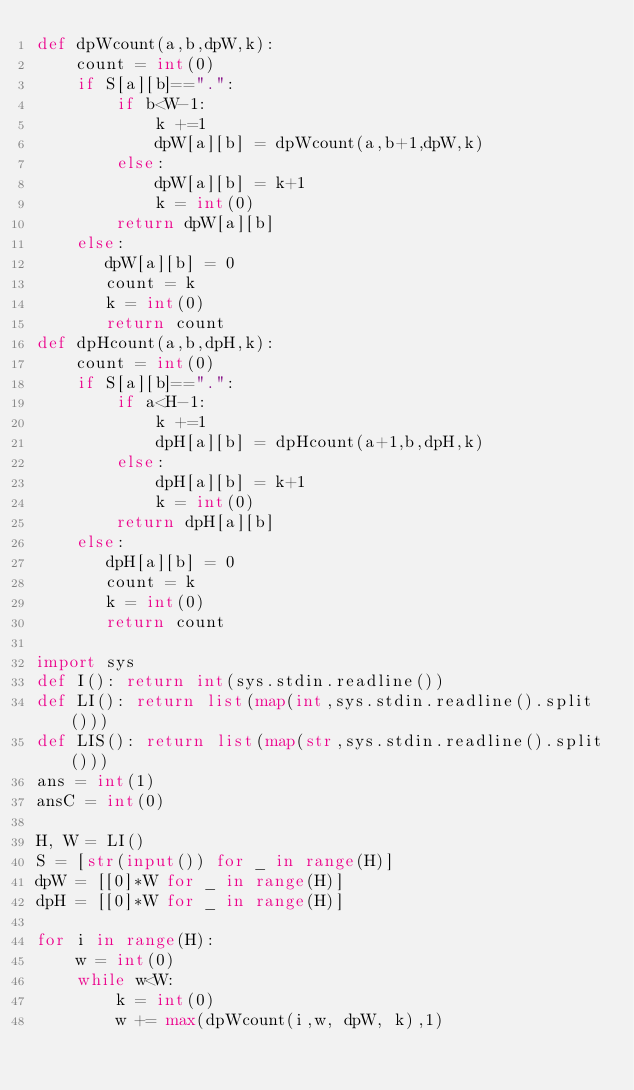<code> <loc_0><loc_0><loc_500><loc_500><_Python_>def dpWcount(a,b,dpW,k):
    count = int(0)
    if S[a][b]==".":
        if b<W-1:
            k +=1
            dpW[a][b] = dpWcount(a,b+1,dpW,k)
        else:
            dpW[a][b] = k+1
            k = int(0)
        return dpW[a][b]
    else:
       dpW[a][b] = 0
       count = k
       k = int(0)
       return count
def dpHcount(a,b,dpH,k):
    count = int(0)
    if S[a][b]==".":
        if a<H-1:
            k +=1
            dpH[a][b] = dpHcount(a+1,b,dpH,k)
        else:
            dpH[a][b] = k+1
            k = int(0)
        return dpH[a][b]
    else:
       dpH[a][b] = 0
       count = k
       k = int(0)
       return count

import sys
def I(): return int(sys.stdin.readline())
def LI(): return list(map(int,sys.stdin.readline().split()))
def LIS(): return list(map(str,sys.stdin.readline().split()))
ans = int(1)
ansC = int(0)

H, W = LI()
S = [str(input()) for _ in range(H)]
dpW = [[0]*W for _ in range(H)]
dpH = [[0]*W for _ in range(H)]

for i in range(H):
    w = int(0)
    while w<W:
        k = int(0)
        w += max(dpWcount(i,w, dpW, k),1)</code> 